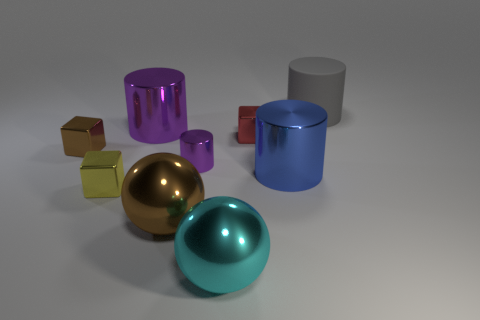The red thing has what size?
Give a very brief answer. Small. What is the material of the large gray cylinder?
Offer a terse response. Rubber. Do the cube that is on the left side of the yellow thing and the large purple shiny cylinder have the same size?
Your response must be concise. No. How many objects are either big cyan things or big yellow metal things?
Your answer should be compact. 1. What is the shape of the object that is the same color as the small cylinder?
Offer a very short reply. Cylinder. What size is the cylinder that is both on the left side of the big blue object and in front of the brown shiny cube?
Ensure brevity in your answer.  Small. How many large green metal spheres are there?
Offer a very short reply. 0. What number of cubes are big yellow matte things or metallic things?
Your response must be concise. 3. There is a big cylinder that is in front of the big cylinder that is on the left side of the brown ball; how many cyan spheres are behind it?
Give a very brief answer. 0. What color is the cylinder that is the same size as the brown metallic block?
Give a very brief answer. Purple. 